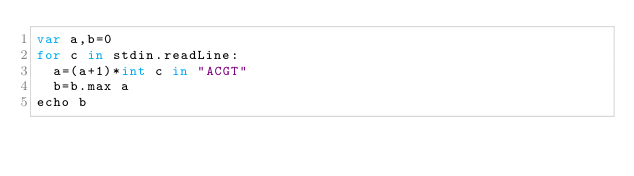<code> <loc_0><loc_0><loc_500><loc_500><_Nim_>var a,b=0
for c in stdin.readLine:
  a=(a+1)*int c in "ACGT"
  b=b.max a
echo b</code> 